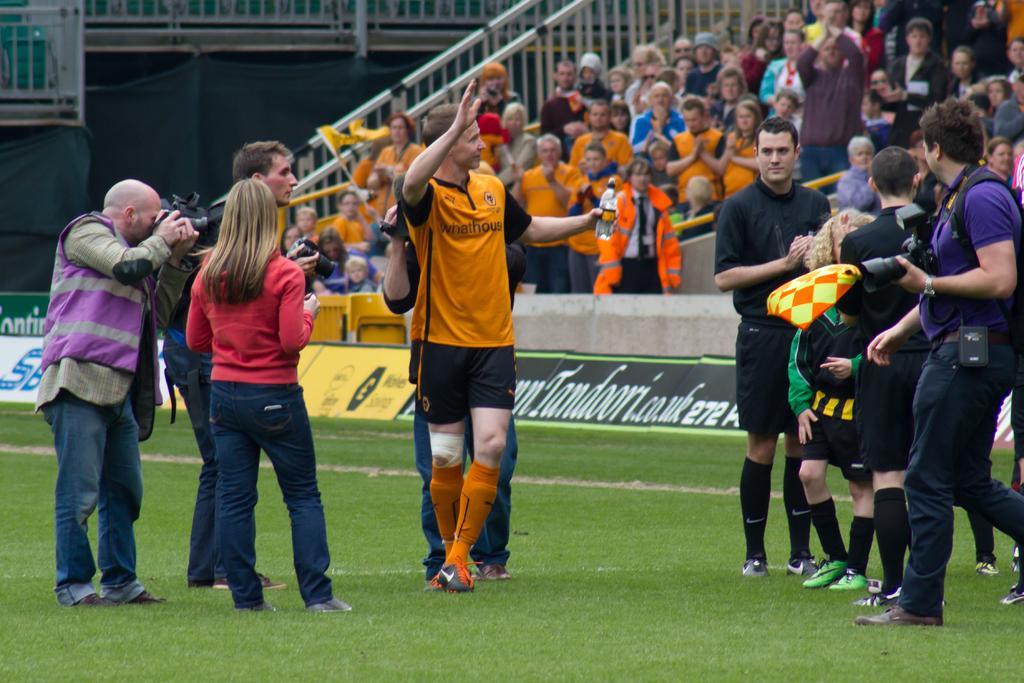Describe this image in one or two sentences. In this image we can see people standing and some of them are holding cameras. In the background there is crowd sitting and we can see railings. At the bottom there is grass. 